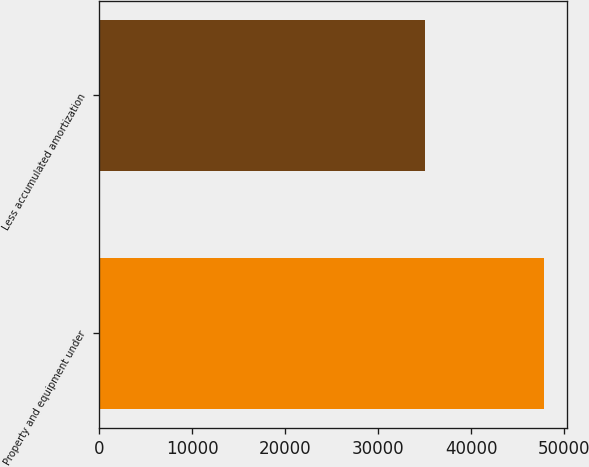Convert chart. <chart><loc_0><loc_0><loc_500><loc_500><bar_chart><fcel>Property and equipment under<fcel>Less accumulated amortization<nl><fcel>47842<fcel>35056<nl></chart> 